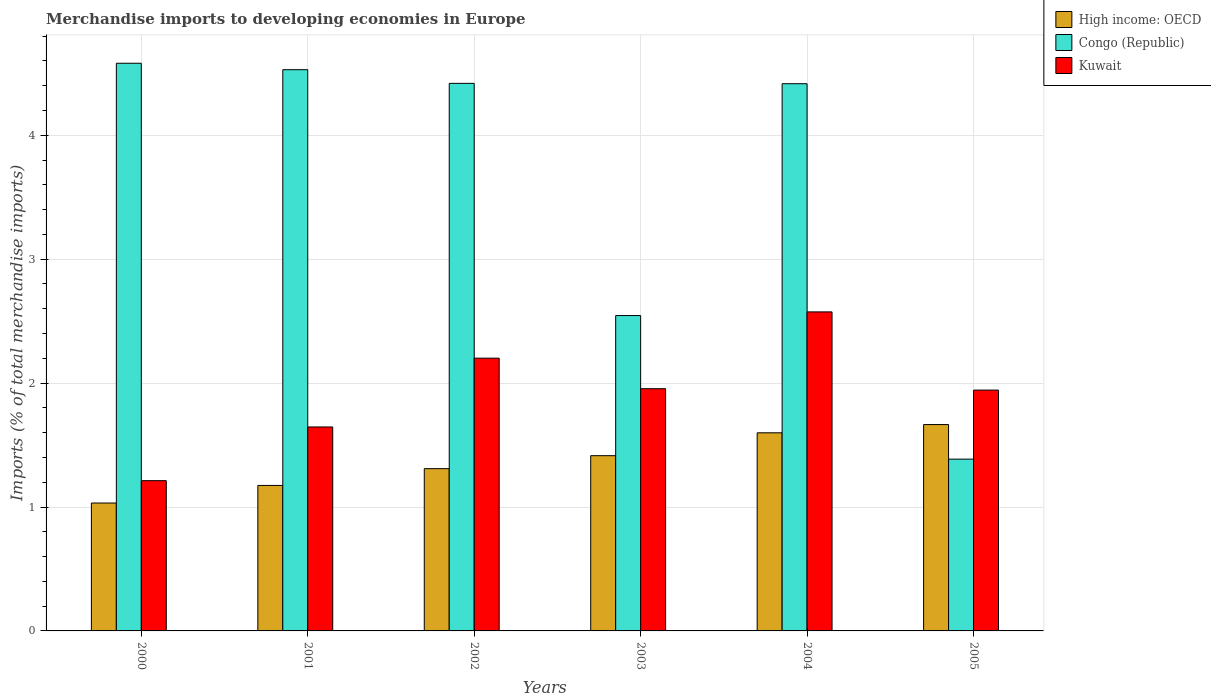How many different coloured bars are there?
Provide a succinct answer. 3. Are the number of bars on each tick of the X-axis equal?
Provide a succinct answer. Yes. How many bars are there on the 1st tick from the left?
Your answer should be very brief. 3. How many bars are there on the 2nd tick from the right?
Keep it short and to the point. 3. What is the percentage total merchandise imports in High income: OECD in 2002?
Your answer should be very brief. 1.31. Across all years, what is the maximum percentage total merchandise imports in High income: OECD?
Your answer should be compact. 1.67. Across all years, what is the minimum percentage total merchandise imports in Congo (Republic)?
Give a very brief answer. 1.39. What is the total percentage total merchandise imports in Congo (Republic) in the graph?
Provide a short and direct response. 21.88. What is the difference between the percentage total merchandise imports in Kuwait in 2000 and that in 2004?
Offer a very short reply. -1.36. What is the difference between the percentage total merchandise imports in Kuwait in 2003 and the percentage total merchandise imports in High income: OECD in 2001?
Ensure brevity in your answer.  0.78. What is the average percentage total merchandise imports in High income: OECD per year?
Ensure brevity in your answer.  1.37. In the year 2005, what is the difference between the percentage total merchandise imports in High income: OECD and percentage total merchandise imports in Congo (Republic)?
Provide a short and direct response. 0.28. What is the ratio of the percentage total merchandise imports in Congo (Republic) in 2002 to that in 2005?
Your answer should be compact. 3.19. What is the difference between the highest and the second highest percentage total merchandise imports in Kuwait?
Give a very brief answer. 0.37. What is the difference between the highest and the lowest percentage total merchandise imports in High income: OECD?
Ensure brevity in your answer.  0.63. What does the 3rd bar from the left in 2004 represents?
Your answer should be compact. Kuwait. What does the 1st bar from the right in 2003 represents?
Offer a very short reply. Kuwait. Are all the bars in the graph horizontal?
Offer a very short reply. No. How many years are there in the graph?
Provide a succinct answer. 6. Are the values on the major ticks of Y-axis written in scientific E-notation?
Make the answer very short. No. How many legend labels are there?
Ensure brevity in your answer.  3. What is the title of the graph?
Provide a succinct answer. Merchandise imports to developing economies in Europe. What is the label or title of the X-axis?
Offer a terse response. Years. What is the label or title of the Y-axis?
Your answer should be compact. Imports (% of total merchandise imports). What is the Imports (% of total merchandise imports) of High income: OECD in 2000?
Your answer should be very brief. 1.03. What is the Imports (% of total merchandise imports) in Congo (Republic) in 2000?
Provide a short and direct response. 4.58. What is the Imports (% of total merchandise imports) of Kuwait in 2000?
Offer a very short reply. 1.21. What is the Imports (% of total merchandise imports) of High income: OECD in 2001?
Ensure brevity in your answer.  1.17. What is the Imports (% of total merchandise imports) in Congo (Republic) in 2001?
Ensure brevity in your answer.  4.53. What is the Imports (% of total merchandise imports) of Kuwait in 2001?
Make the answer very short. 1.65. What is the Imports (% of total merchandise imports) of High income: OECD in 2002?
Provide a succinct answer. 1.31. What is the Imports (% of total merchandise imports) in Congo (Republic) in 2002?
Provide a succinct answer. 4.42. What is the Imports (% of total merchandise imports) of Kuwait in 2002?
Offer a very short reply. 2.2. What is the Imports (% of total merchandise imports) of High income: OECD in 2003?
Provide a short and direct response. 1.41. What is the Imports (% of total merchandise imports) of Congo (Republic) in 2003?
Offer a very short reply. 2.55. What is the Imports (% of total merchandise imports) in Kuwait in 2003?
Provide a short and direct response. 1.95. What is the Imports (% of total merchandise imports) of High income: OECD in 2004?
Your answer should be very brief. 1.6. What is the Imports (% of total merchandise imports) in Congo (Republic) in 2004?
Keep it short and to the point. 4.42. What is the Imports (% of total merchandise imports) in Kuwait in 2004?
Keep it short and to the point. 2.57. What is the Imports (% of total merchandise imports) in High income: OECD in 2005?
Provide a succinct answer. 1.67. What is the Imports (% of total merchandise imports) in Congo (Republic) in 2005?
Keep it short and to the point. 1.39. What is the Imports (% of total merchandise imports) in Kuwait in 2005?
Provide a short and direct response. 1.94. Across all years, what is the maximum Imports (% of total merchandise imports) of High income: OECD?
Your response must be concise. 1.67. Across all years, what is the maximum Imports (% of total merchandise imports) of Congo (Republic)?
Make the answer very short. 4.58. Across all years, what is the maximum Imports (% of total merchandise imports) in Kuwait?
Offer a very short reply. 2.57. Across all years, what is the minimum Imports (% of total merchandise imports) in High income: OECD?
Make the answer very short. 1.03. Across all years, what is the minimum Imports (% of total merchandise imports) in Congo (Republic)?
Offer a very short reply. 1.39. Across all years, what is the minimum Imports (% of total merchandise imports) in Kuwait?
Keep it short and to the point. 1.21. What is the total Imports (% of total merchandise imports) of High income: OECD in the graph?
Your answer should be compact. 8.19. What is the total Imports (% of total merchandise imports) in Congo (Republic) in the graph?
Give a very brief answer. 21.88. What is the total Imports (% of total merchandise imports) of Kuwait in the graph?
Offer a very short reply. 11.53. What is the difference between the Imports (% of total merchandise imports) in High income: OECD in 2000 and that in 2001?
Make the answer very short. -0.14. What is the difference between the Imports (% of total merchandise imports) in Congo (Republic) in 2000 and that in 2001?
Your answer should be very brief. 0.05. What is the difference between the Imports (% of total merchandise imports) of Kuwait in 2000 and that in 2001?
Offer a terse response. -0.43. What is the difference between the Imports (% of total merchandise imports) in High income: OECD in 2000 and that in 2002?
Provide a succinct answer. -0.28. What is the difference between the Imports (% of total merchandise imports) in Congo (Republic) in 2000 and that in 2002?
Provide a succinct answer. 0.16. What is the difference between the Imports (% of total merchandise imports) in Kuwait in 2000 and that in 2002?
Give a very brief answer. -0.99. What is the difference between the Imports (% of total merchandise imports) in High income: OECD in 2000 and that in 2003?
Your answer should be compact. -0.38. What is the difference between the Imports (% of total merchandise imports) in Congo (Republic) in 2000 and that in 2003?
Offer a very short reply. 2.04. What is the difference between the Imports (% of total merchandise imports) in Kuwait in 2000 and that in 2003?
Offer a terse response. -0.74. What is the difference between the Imports (% of total merchandise imports) of High income: OECD in 2000 and that in 2004?
Keep it short and to the point. -0.57. What is the difference between the Imports (% of total merchandise imports) of Congo (Republic) in 2000 and that in 2004?
Make the answer very short. 0.17. What is the difference between the Imports (% of total merchandise imports) in Kuwait in 2000 and that in 2004?
Make the answer very short. -1.36. What is the difference between the Imports (% of total merchandise imports) of High income: OECD in 2000 and that in 2005?
Your answer should be very brief. -0.63. What is the difference between the Imports (% of total merchandise imports) of Congo (Republic) in 2000 and that in 2005?
Your answer should be compact. 3.19. What is the difference between the Imports (% of total merchandise imports) of Kuwait in 2000 and that in 2005?
Provide a short and direct response. -0.73. What is the difference between the Imports (% of total merchandise imports) in High income: OECD in 2001 and that in 2002?
Provide a short and direct response. -0.14. What is the difference between the Imports (% of total merchandise imports) of Congo (Republic) in 2001 and that in 2002?
Your answer should be compact. 0.11. What is the difference between the Imports (% of total merchandise imports) of Kuwait in 2001 and that in 2002?
Offer a terse response. -0.56. What is the difference between the Imports (% of total merchandise imports) of High income: OECD in 2001 and that in 2003?
Your response must be concise. -0.24. What is the difference between the Imports (% of total merchandise imports) in Congo (Republic) in 2001 and that in 2003?
Your answer should be compact. 1.98. What is the difference between the Imports (% of total merchandise imports) in Kuwait in 2001 and that in 2003?
Offer a terse response. -0.31. What is the difference between the Imports (% of total merchandise imports) of High income: OECD in 2001 and that in 2004?
Your answer should be compact. -0.42. What is the difference between the Imports (% of total merchandise imports) of Congo (Republic) in 2001 and that in 2004?
Offer a terse response. 0.11. What is the difference between the Imports (% of total merchandise imports) of Kuwait in 2001 and that in 2004?
Your answer should be very brief. -0.93. What is the difference between the Imports (% of total merchandise imports) of High income: OECD in 2001 and that in 2005?
Your response must be concise. -0.49. What is the difference between the Imports (% of total merchandise imports) in Congo (Republic) in 2001 and that in 2005?
Keep it short and to the point. 3.14. What is the difference between the Imports (% of total merchandise imports) of Kuwait in 2001 and that in 2005?
Keep it short and to the point. -0.3. What is the difference between the Imports (% of total merchandise imports) in High income: OECD in 2002 and that in 2003?
Give a very brief answer. -0.1. What is the difference between the Imports (% of total merchandise imports) in Congo (Republic) in 2002 and that in 2003?
Give a very brief answer. 1.87. What is the difference between the Imports (% of total merchandise imports) in Kuwait in 2002 and that in 2003?
Offer a very short reply. 0.25. What is the difference between the Imports (% of total merchandise imports) in High income: OECD in 2002 and that in 2004?
Provide a succinct answer. -0.29. What is the difference between the Imports (% of total merchandise imports) in Congo (Republic) in 2002 and that in 2004?
Provide a succinct answer. 0. What is the difference between the Imports (% of total merchandise imports) of Kuwait in 2002 and that in 2004?
Your answer should be compact. -0.37. What is the difference between the Imports (% of total merchandise imports) of High income: OECD in 2002 and that in 2005?
Your answer should be very brief. -0.36. What is the difference between the Imports (% of total merchandise imports) of Congo (Republic) in 2002 and that in 2005?
Your answer should be compact. 3.03. What is the difference between the Imports (% of total merchandise imports) in Kuwait in 2002 and that in 2005?
Offer a terse response. 0.26. What is the difference between the Imports (% of total merchandise imports) in High income: OECD in 2003 and that in 2004?
Offer a very short reply. -0.18. What is the difference between the Imports (% of total merchandise imports) in Congo (Republic) in 2003 and that in 2004?
Your answer should be compact. -1.87. What is the difference between the Imports (% of total merchandise imports) in Kuwait in 2003 and that in 2004?
Give a very brief answer. -0.62. What is the difference between the Imports (% of total merchandise imports) in High income: OECD in 2003 and that in 2005?
Give a very brief answer. -0.25. What is the difference between the Imports (% of total merchandise imports) of Congo (Republic) in 2003 and that in 2005?
Provide a short and direct response. 1.16. What is the difference between the Imports (% of total merchandise imports) of Kuwait in 2003 and that in 2005?
Offer a very short reply. 0.01. What is the difference between the Imports (% of total merchandise imports) in High income: OECD in 2004 and that in 2005?
Offer a very short reply. -0.07. What is the difference between the Imports (% of total merchandise imports) in Congo (Republic) in 2004 and that in 2005?
Give a very brief answer. 3.03. What is the difference between the Imports (% of total merchandise imports) in Kuwait in 2004 and that in 2005?
Give a very brief answer. 0.63. What is the difference between the Imports (% of total merchandise imports) of High income: OECD in 2000 and the Imports (% of total merchandise imports) of Congo (Republic) in 2001?
Your answer should be compact. -3.5. What is the difference between the Imports (% of total merchandise imports) in High income: OECD in 2000 and the Imports (% of total merchandise imports) in Kuwait in 2001?
Your answer should be very brief. -0.61. What is the difference between the Imports (% of total merchandise imports) of Congo (Republic) in 2000 and the Imports (% of total merchandise imports) of Kuwait in 2001?
Make the answer very short. 2.94. What is the difference between the Imports (% of total merchandise imports) of High income: OECD in 2000 and the Imports (% of total merchandise imports) of Congo (Republic) in 2002?
Your response must be concise. -3.39. What is the difference between the Imports (% of total merchandise imports) of High income: OECD in 2000 and the Imports (% of total merchandise imports) of Kuwait in 2002?
Ensure brevity in your answer.  -1.17. What is the difference between the Imports (% of total merchandise imports) of Congo (Republic) in 2000 and the Imports (% of total merchandise imports) of Kuwait in 2002?
Make the answer very short. 2.38. What is the difference between the Imports (% of total merchandise imports) in High income: OECD in 2000 and the Imports (% of total merchandise imports) in Congo (Republic) in 2003?
Your answer should be compact. -1.51. What is the difference between the Imports (% of total merchandise imports) of High income: OECD in 2000 and the Imports (% of total merchandise imports) of Kuwait in 2003?
Give a very brief answer. -0.92. What is the difference between the Imports (% of total merchandise imports) in Congo (Republic) in 2000 and the Imports (% of total merchandise imports) in Kuwait in 2003?
Offer a terse response. 2.63. What is the difference between the Imports (% of total merchandise imports) of High income: OECD in 2000 and the Imports (% of total merchandise imports) of Congo (Republic) in 2004?
Offer a very short reply. -3.38. What is the difference between the Imports (% of total merchandise imports) in High income: OECD in 2000 and the Imports (% of total merchandise imports) in Kuwait in 2004?
Give a very brief answer. -1.54. What is the difference between the Imports (% of total merchandise imports) of Congo (Republic) in 2000 and the Imports (% of total merchandise imports) of Kuwait in 2004?
Keep it short and to the point. 2.01. What is the difference between the Imports (% of total merchandise imports) of High income: OECD in 2000 and the Imports (% of total merchandise imports) of Congo (Republic) in 2005?
Keep it short and to the point. -0.35. What is the difference between the Imports (% of total merchandise imports) in High income: OECD in 2000 and the Imports (% of total merchandise imports) in Kuwait in 2005?
Ensure brevity in your answer.  -0.91. What is the difference between the Imports (% of total merchandise imports) in Congo (Republic) in 2000 and the Imports (% of total merchandise imports) in Kuwait in 2005?
Provide a short and direct response. 2.64. What is the difference between the Imports (% of total merchandise imports) in High income: OECD in 2001 and the Imports (% of total merchandise imports) in Congo (Republic) in 2002?
Your answer should be compact. -3.24. What is the difference between the Imports (% of total merchandise imports) of High income: OECD in 2001 and the Imports (% of total merchandise imports) of Kuwait in 2002?
Provide a succinct answer. -1.03. What is the difference between the Imports (% of total merchandise imports) in Congo (Republic) in 2001 and the Imports (% of total merchandise imports) in Kuwait in 2002?
Make the answer very short. 2.33. What is the difference between the Imports (% of total merchandise imports) in High income: OECD in 2001 and the Imports (% of total merchandise imports) in Congo (Republic) in 2003?
Ensure brevity in your answer.  -1.37. What is the difference between the Imports (% of total merchandise imports) in High income: OECD in 2001 and the Imports (% of total merchandise imports) in Kuwait in 2003?
Your answer should be compact. -0.78. What is the difference between the Imports (% of total merchandise imports) in Congo (Republic) in 2001 and the Imports (% of total merchandise imports) in Kuwait in 2003?
Your answer should be very brief. 2.57. What is the difference between the Imports (% of total merchandise imports) in High income: OECD in 2001 and the Imports (% of total merchandise imports) in Congo (Republic) in 2004?
Offer a terse response. -3.24. What is the difference between the Imports (% of total merchandise imports) in High income: OECD in 2001 and the Imports (% of total merchandise imports) in Kuwait in 2004?
Provide a succinct answer. -1.4. What is the difference between the Imports (% of total merchandise imports) in Congo (Republic) in 2001 and the Imports (% of total merchandise imports) in Kuwait in 2004?
Provide a short and direct response. 1.95. What is the difference between the Imports (% of total merchandise imports) of High income: OECD in 2001 and the Imports (% of total merchandise imports) of Congo (Republic) in 2005?
Your answer should be very brief. -0.21. What is the difference between the Imports (% of total merchandise imports) of High income: OECD in 2001 and the Imports (% of total merchandise imports) of Kuwait in 2005?
Your answer should be compact. -0.77. What is the difference between the Imports (% of total merchandise imports) of Congo (Republic) in 2001 and the Imports (% of total merchandise imports) of Kuwait in 2005?
Provide a succinct answer. 2.59. What is the difference between the Imports (% of total merchandise imports) of High income: OECD in 2002 and the Imports (% of total merchandise imports) of Congo (Republic) in 2003?
Your response must be concise. -1.24. What is the difference between the Imports (% of total merchandise imports) in High income: OECD in 2002 and the Imports (% of total merchandise imports) in Kuwait in 2003?
Provide a succinct answer. -0.65. What is the difference between the Imports (% of total merchandise imports) in Congo (Republic) in 2002 and the Imports (% of total merchandise imports) in Kuwait in 2003?
Provide a succinct answer. 2.46. What is the difference between the Imports (% of total merchandise imports) in High income: OECD in 2002 and the Imports (% of total merchandise imports) in Congo (Republic) in 2004?
Your answer should be very brief. -3.11. What is the difference between the Imports (% of total merchandise imports) in High income: OECD in 2002 and the Imports (% of total merchandise imports) in Kuwait in 2004?
Offer a terse response. -1.27. What is the difference between the Imports (% of total merchandise imports) of Congo (Republic) in 2002 and the Imports (% of total merchandise imports) of Kuwait in 2004?
Your response must be concise. 1.84. What is the difference between the Imports (% of total merchandise imports) in High income: OECD in 2002 and the Imports (% of total merchandise imports) in Congo (Republic) in 2005?
Your answer should be very brief. -0.08. What is the difference between the Imports (% of total merchandise imports) in High income: OECD in 2002 and the Imports (% of total merchandise imports) in Kuwait in 2005?
Make the answer very short. -0.63. What is the difference between the Imports (% of total merchandise imports) in Congo (Republic) in 2002 and the Imports (% of total merchandise imports) in Kuwait in 2005?
Keep it short and to the point. 2.48. What is the difference between the Imports (% of total merchandise imports) of High income: OECD in 2003 and the Imports (% of total merchandise imports) of Congo (Republic) in 2004?
Make the answer very short. -3. What is the difference between the Imports (% of total merchandise imports) of High income: OECD in 2003 and the Imports (% of total merchandise imports) of Kuwait in 2004?
Your answer should be compact. -1.16. What is the difference between the Imports (% of total merchandise imports) in Congo (Republic) in 2003 and the Imports (% of total merchandise imports) in Kuwait in 2004?
Ensure brevity in your answer.  -0.03. What is the difference between the Imports (% of total merchandise imports) in High income: OECD in 2003 and the Imports (% of total merchandise imports) in Congo (Republic) in 2005?
Keep it short and to the point. 0.03. What is the difference between the Imports (% of total merchandise imports) in High income: OECD in 2003 and the Imports (% of total merchandise imports) in Kuwait in 2005?
Provide a short and direct response. -0.53. What is the difference between the Imports (% of total merchandise imports) of Congo (Republic) in 2003 and the Imports (% of total merchandise imports) of Kuwait in 2005?
Keep it short and to the point. 0.6. What is the difference between the Imports (% of total merchandise imports) of High income: OECD in 2004 and the Imports (% of total merchandise imports) of Congo (Republic) in 2005?
Provide a succinct answer. 0.21. What is the difference between the Imports (% of total merchandise imports) of High income: OECD in 2004 and the Imports (% of total merchandise imports) of Kuwait in 2005?
Keep it short and to the point. -0.34. What is the difference between the Imports (% of total merchandise imports) of Congo (Republic) in 2004 and the Imports (% of total merchandise imports) of Kuwait in 2005?
Give a very brief answer. 2.47. What is the average Imports (% of total merchandise imports) of High income: OECD per year?
Provide a short and direct response. 1.37. What is the average Imports (% of total merchandise imports) of Congo (Republic) per year?
Your answer should be very brief. 3.65. What is the average Imports (% of total merchandise imports) in Kuwait per year?
Give a very brief answer. 1.92. In the year 2000, what is the difference between the Imports (% of total merchandise imports) in High income: OECD and Imports (% of total merchandise imports) in Congo (Republic)?
Offer a terse response. -3.55. In the year 2000, what is the difference between the Imports (% of total merchandise imports) in High income: OECD and Imports (% of total merchandise imports) in Kuwait?
Your response must be concise. -0.18. In the year 2000, what is the difference between the Imports (% of total merchandise imports) of Congo (Republic) and Imports (% of total merchandise imports) of Kuwait?
Provide a short and direct response. 3.37. In the year 2001, what is the difference between the Imports (% of total merchandise imports) in High income: OECD and Imports (% of total merchandise imports) in Congo (Republic)?
Offer a terse response. -3.36. In the year 2001, what is the difference between the Imports (% of total merchandise imports) of High income: OECD and Imports (% of total merchandise imports) of Kuwait?
Make the answer very short. -0.47. In the year 2001, what is the difference between the Imports (% of total merchandise imports) of Congo (Republic) and Imports (% of total merchandise imports) of Kuwait?
Offer a terse response. 2.88. In the year 2002, what is the difference between the Imports (% of total merchandise imports) in High income: OECD and Imports (% of total merchandise imports) in Congo (Republic)?
Offer a terse response. -3.11. In the year 2002, what is the difference between the Imports (% of total merchandise imports) of High income: OECD and Imports (% of total merchandise imports) of Kuwait?
Keep it short and to the point. -0.89. In the year 2002, what is the difference between the Imports (% of total merchandise imports) of Congo (Republic) and Imports (% of total merchandise imports) of Kuwait?
Provide a succinct answer. 2.22. In the year 2003, what is the difference between the Imports (% of total merchandise imports) in High income: OECD and Imports (% of total merchandise imports) in Congo (Republic)?
Give a very brief answer. -1.13. In the year 2003, what is the difference between the Imports (% of total merchandise imports) of High income: OECD and Imports (% of total merchandise imports) of Kuwait?
Provide a short and direct response. -0.54. In the year 2003, what is the difference between the Imports (% of total merchandise imports) in Congo (Republic) and Imports (% of total merchandise imports) in Kuwait?
Offer a terse response. 0.59. In the year 2004, what is the difference between the Imports (% of total merchandise imports) of High income: OECD and Imports (% of total merchandise imports) of Congo (Republic)?
Provide a short and direct response. -2.82. In the year 2004, what is the difference between the Imports (% of total merchandise imports) of High income: OECD and Imports (% of total merchandise imports) of Kuwait?
Make the answer very short. -0.98. In the year 2004, what is the difference between the Imports (% of total merchandise imports) in Congo (Republic) and Imports (% of total merchandise imports) in Kuwait?
Your answer should be compact. 1.84. In the year 2005, what is the difference between the Imports (% of total merchandise imports) of High income: OECD and Imports (% of total merchandise imports) of Congo (Republic)?
Provide a short and direct response. 0.28. In the year 2005, what is the difference between the Imports (% of total merchandise imports) in High income: OECD and Imports (% of total merchandise imports) in Kuwait?
Offer a very short reply. -0.28. In the year 2005, what is the difference between the Imports (% of total merchandise imports) in Congo (Republic) and Imports (% of total merchandise imports) in Kuwait?
Make the answer very short. -0.56. What is the ratio of the Imports (% of total merchandise imports) in High income: OECD in 2000 to that in 2001?
Offer a terse response. 0.88. What is the ratio of the Imports (% of total merchandise imports) of Congo (Republic) in 2000 to that in 2001?
Ensure brevity in your answer.  1.01. What is the ratio of the Imports (% of total merchandise imports) in Kuwait in 2000 to that in 2001?
Give a very brief answer. 0.74. What is the ratio of the Imports (% of total merchandise imports) of High income: OECD in 2000 to that in 2002?
Offer a terse response. 0.79. What is the ratio of the Imports (% of total merchandise imports) in Congo (Republic) in 2000 to that in 2002?
Provide a short and direct response. 1.04. What is the ratio of the Imports (% of total merchandise imports) of Kuwait in 2000 to that in 2002?
Ensure brevity in your answer.  0.55. What is the ratio of the Imports (% of total merchandise imports) of High income: OECD in 2000 to that in 2003?
Make the answer very short. 0.73. What is the ratio of the Imports (% of total merchandise imports) in Congo (Republic) in 2000 to that in 2003?
Provide a succinct answer. 1.8. What is the ratio of the Imports (% of total merchandise imports) in Kuwait in 2000 to that in 2003?
Make the answer very short. 0.62. What is the ratio of the Imports (% of total merchandise imports) of High income: OECD in 2000 to that in 2004?
Provide a short and direct response. 0.65. What is the ratio of the Imports (% of total merchandise imports) of Congo (Republic) in 2000 to that in 2004?
Ensure brevity in your answer.  1.04. What is the ratio of the Imports (% of total merchandise imports) in Kuwait in 2000 to that in 2004?
Give a very brief answer. 0.47. What is the ratio of the Imports (% of total merchandise imports) of High income: OECD in 2000 to that in 2005?
Your response must be concise. 0.62. What is the ratio of the Imports (% of total merchandise imports) of Congo (Republic) in 2000 to that in 2005?
Ensure brevity in your answer.  3.3. What is the ratio of the Imports (% of total merchandise imports) in Kuwait in 2000 to that in 2005?
Make the answer very short. 0.62. What is the ratio of the Imports (% of total merchandise imports) of High income: OECD in 2001 to that in 2002?
Make the answer very short. 0.9. What is the ratio of the Imports (% of total merchandise imports) of Congo (Republic) in 2001 to that in 2002?
Offer a terse response. 1.02. What is the ratio of the Imports (% of total merchandise imports) of Kuwait in 2001 to that in 2002?
Offer a very short reply. 0.75. What is the ratio of the Imports (% of total merchandise imports) in High income: OECD in 2001 to that in 2003?
Give a very brief answer. 0.83. What is the ratio of the Imports (% of total merchandise imports) in Congo (Republic) in 2001 to that in 2003?
Provide a succinct answer. 1.78. What is the ratio of the Imports (% of total merchandise imports) of Kuwait in 2001 to that in 2003?
Your response must be concise. 0.84. What is the ratio of the Imports (% of total merchandise imports) of High income: OECD in 2001 to that in 2004?
Ensure brevity in your answer.  0.73. What is the ratio of the Imports (% of total merchandise imports) of Congo (Republic) in 2001 to that in 2004?
Offer a terse response. 1.03. What is the ratio of the Imports (% of total merchandise imports) of Kuwait in 2001 to that in 2004?
Ensure brevity in your answer.  0.64. What is the ratio of the Imports (% of total merchandise imports) of High income: OECD in 2001 to that in 2005?
Offer a very short reply. 0.7. What is the ratio of the Imports (% of total merchandise imports) in Congo (Republic) in 2001 to that in 2005?
Your answer should be very brief. 3.27. What is the ratio of the Imports (% of total merchandise imports) of Kuwait in 2001 to that in 2005?
Give a very brief answer. 0.85. What is the ratio of the Imports (% of total merchandise imports) of High income: OECD in 2002 to that in 2003?
Provide a succinct answer. 0.93. What is the ratio of the Imports (% of total merchandise imports) of Congo (Republic) in 2002 to that in 2003?
Give a very brief answer. 1.74. What is the ratio of the Imports (% of total merchandise imports) of Kuwait in 2002 to that in 2003?
Keep it short and to the point. 1.13. What is the ratio of the Imports (% of total merchandise imports) in High income: OECD in 2002 to that in 2004?
Offer a very short reply. 0.82. What is the ratio of the Imports (% of total merchandise imports) of Congo (Republic) in 2002 to that in 2004?
Provide a short and direct response. 1. What is the ratio of the Imports (% of total merchandise imports) in Kuwait in 2002 to that in 2004?
Offer a very short reply. 0.85. What is the ratio of the Imports (% of total merchandise imports) in High income: OECD in 2002 to that in 2005?
Provide a succinct answer. 0.79. What is the ratio of the Imports (% of total merchandise imports) in Congo (Republic) in 2002 to that in 2005?
Your answer should be compact. 3.19. What is the ratio of the Imports (% of total merchandise imports) of Kuwait in 2002 to that in 2005?
Your answer should be very brief. 1.13. What is the ratio of the Imports (% of total merchandise imports) in High income: OECD in 2003 to that in 2004?
Your answer should be very brief. 0.88. What is the ratio of the Imports (% of total merchandise imports) in Congo (Republic) in 2003 to that in 2004?
Provide a short and direct response. 0.58. What is the ratio of the Imports (% of total merchandise imports) of Kuwait in 2003 to that in 2004?
Provide a short and direct response. 0.76. What is the ratio of the Imports (% of total merchandise imports) in High income: OECD in 2003 to that in 2005?
Offer a terse response. 0.85. What is the ratio of the Imports (% of total merchandise imports) in Congo (Republic) in 2003 to that in 2005?
Give a very brief answer. 1.84. What is the ratio of the Imports (% of total merchandise imports) in Kuwait in 2003 to that in 2005?
Provide a succinct answer. 1.01. What is the ratio of the Imports (% of total merchandise imports) in High income: OECD in 2004 to that in 2005?
Offer a terse response. 0.96. What is the ratio of the Imports (% of total merchandise imports) in Congo (Republic) in 2004 to that in 2005?
Offer a very short reply. 3.19. What is the ratio of the Imports (% of total merchandise imports) of Kuwait in 2004 to that in 2005?
Your answer should be compact. 1.32. What is the difference between the highest and the second highest Imports (% of total merchandise imports) in High income: OECD?
Give a very brief answer. 0.07. What is the difference between the highest and the second highest Imports (% of total merchandise imports) of Congo (Republic)?
Offer a terse response. 0.05. What is the difference between the highest and the second highest Imports (% of total merchandise imports) of Kuwait?
Keep it short and to the point. 0.37. What is the difference between the highest and the lowest Imports (% of total merchandise imports) in High income: OECD?
Ensure brevity in your answer.  0.63. What is the difference between the highest and the lowest Imports (% of total merchandise imports) of Congo (Republic)?
Give a very brief answer. 3.19. What is the difference between the highest and the lowest Imports (% of total merchandise imports) in Kuwait?
Provide a succinct answer. 1.36. 